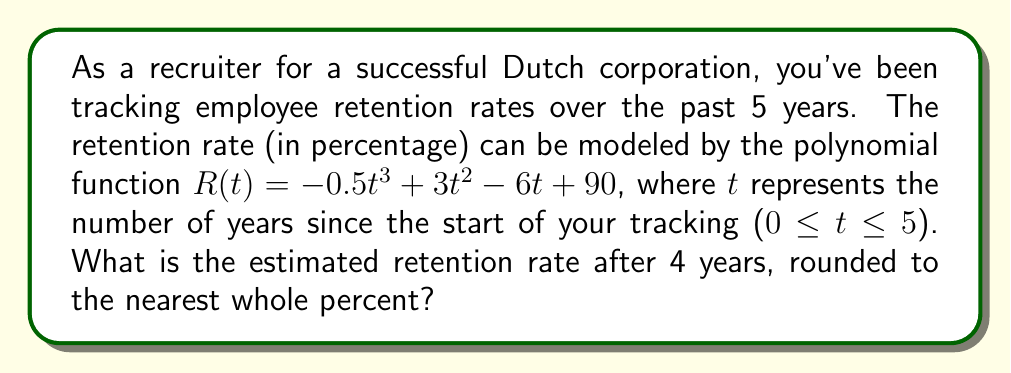Solve this math problem. To solve this problem, we need to follow these steps:

1) We are given the polynomial function for the retention rate:
   $$R(t) = -0.5t^3 + 3t^2 - 6t + 90$$

2) We need to find R(4), as we want the retention rate after 4 years:
   $$R(4) = -0.5(4)^3 + 3(4)^2 - 6(4) + 90$$

3) Let's calculate each term:
   - $-0.5(4)^3 = -0.5 * 64 = -32$
   - $3(4)^2 = 3 * 16 = 48$
   - $-6(4) = -24$
   - The constant term is 90

4) Now, let's sum these terms:
   $$R(4) = -32 + 48 - 24 + 90 = 82$$

5) The question asks for the answer rounded to the nearest whole percent, so our final answer is 82%.
Answer: 82% 